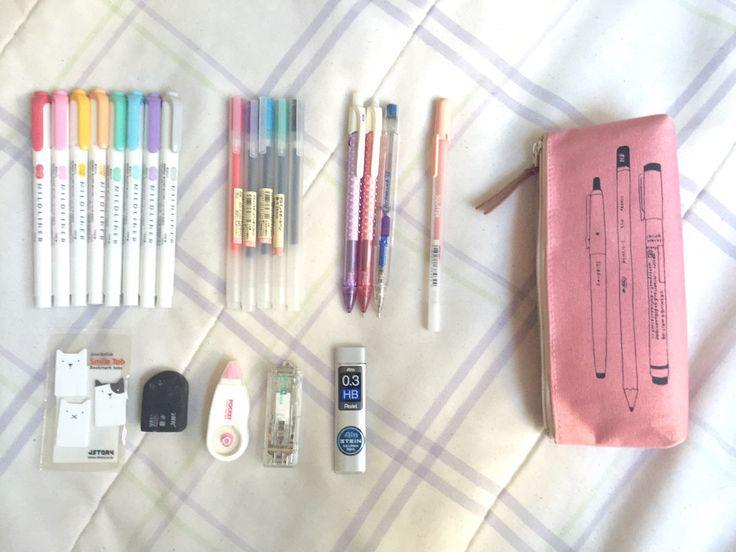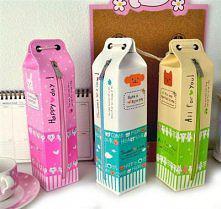The first image is the image on the left, the second image is the image on the right. Assess this claim about the two images: "An image shows an opened case flanked by multiple different type implements.". Correct or not? Answer yes or no. No. 